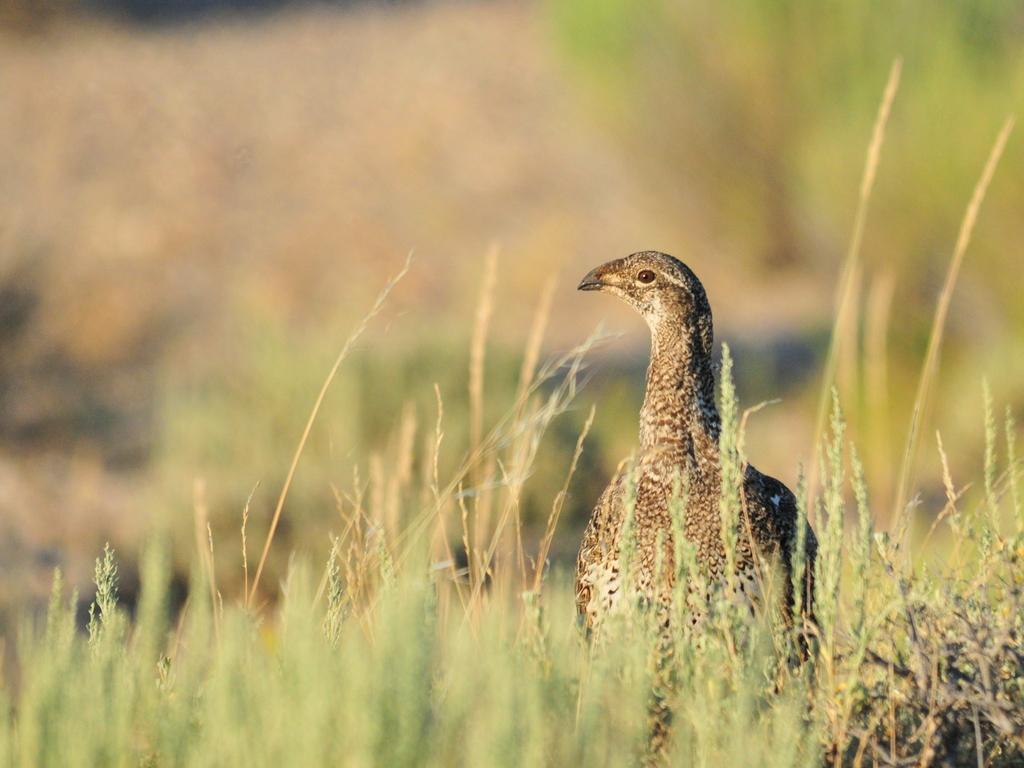Can you describe this image briefly? In this picture I can see few plants and a bird at the bottom. 